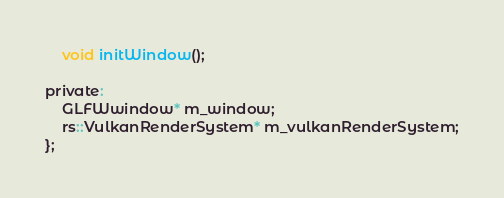<code> <loc_0><loc_0><loc_500><loc_500><_C_>	void initWindow();

private:
	GLFWwindow* m_window;
	rs::VulkanRenderSystem* m_vulkanRenderSystem;
};
</code> 